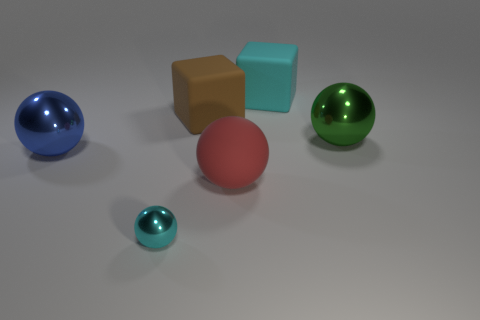Subtract all large green spheres. How many spheres are left? 3 Add 2 large blue objects. How many objects exist? 8 Subtract all green spheres. How many spheres are left? 3 Subtract all balls. How many objects are left? 2 Subtract 1 cyan balls. How many objects are left? 5 Subtract all brown cubes. Subtract all purple balls. How many cubes are left? 1 Subtract all blue objects. Subtract all balls. How many objects are left? 1 Add 2 rubber cubes. How many rubber cubes are left? 4 Add 2 big gray balls. How many big gray balls exist? 2 